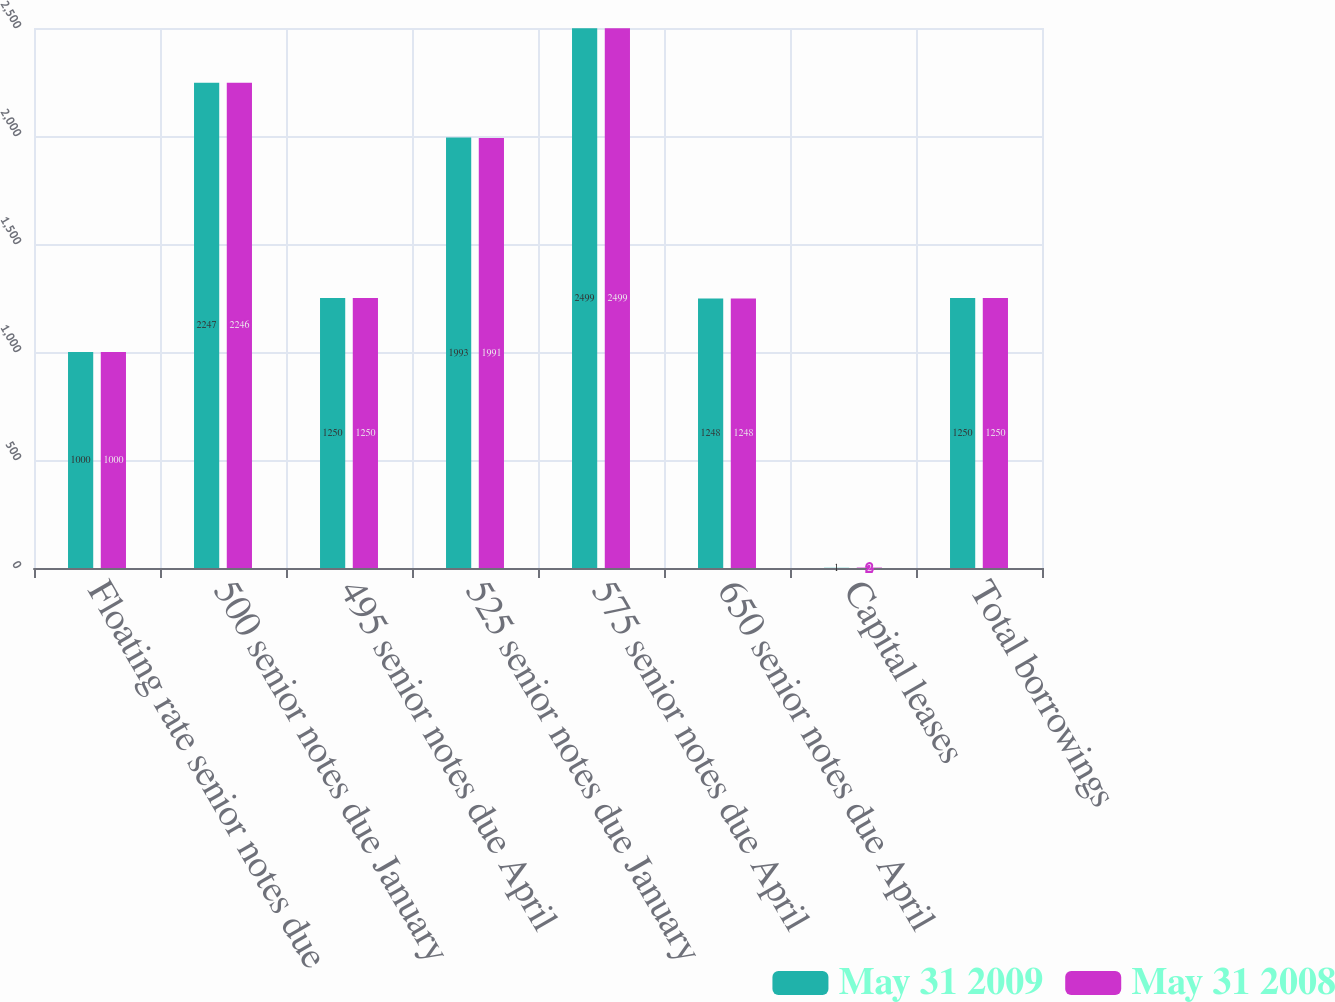<chart> <loc_0><loc_0><loc_500><loc_500><stacked_bar_chart><ecel><fcel>Floating rate senior notes due<fcel>500 senior notes due January<fcel>495 senior notes due April<fcel>525 senior notes due January<fcel>575 senior notes due April<fcel>650 senior notes due April<fcel>Capital leases<fcel>Total borrowings<nl><fcel>May 31 2009<fcel>1000<fcel>2247<fcel>1250<fcel>1993<fcel>2499<fcel>1248<fcel>1<fcel>1250<nl><fcel>May 31 2008<fcel>1000<fcel>2246<fcel>1250<fcel>1991<fcel>2499<fcel>1248<fcel>2<fcel>1250<nl></chart> 